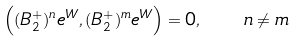<formula> <loc_0><loc_0><loc_500><loc_500>\left ( ( B _ { 2 } ^ { + } ) ^ { n } e ^ { W } , ( B _ { 2 } ^ { + } ) ^ { m } e ^ { W } \right ) = 0 , \quad n \neq m</formula> 